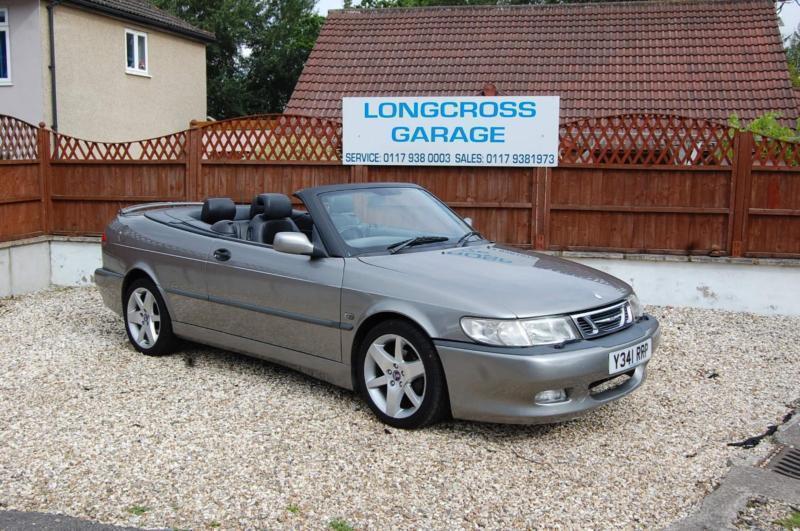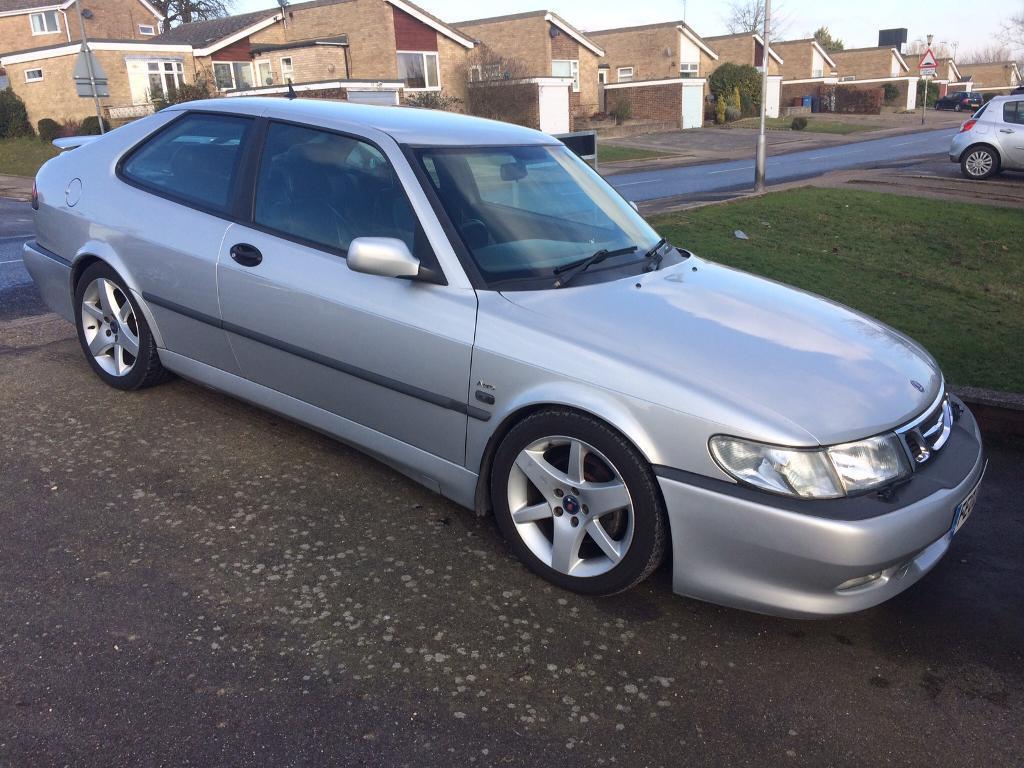The first image is the image on the left, the second image is the image on the right. For the images displayed, is the sentence "Each image shows a grey convertible." factually correct? Answer yes or no. No. The first image is the image on the left, the second image is the image on the right. Assess this claim about the two images: "The convertible in the right image has its top off.". Correct or not? Answer yes or no. No. 